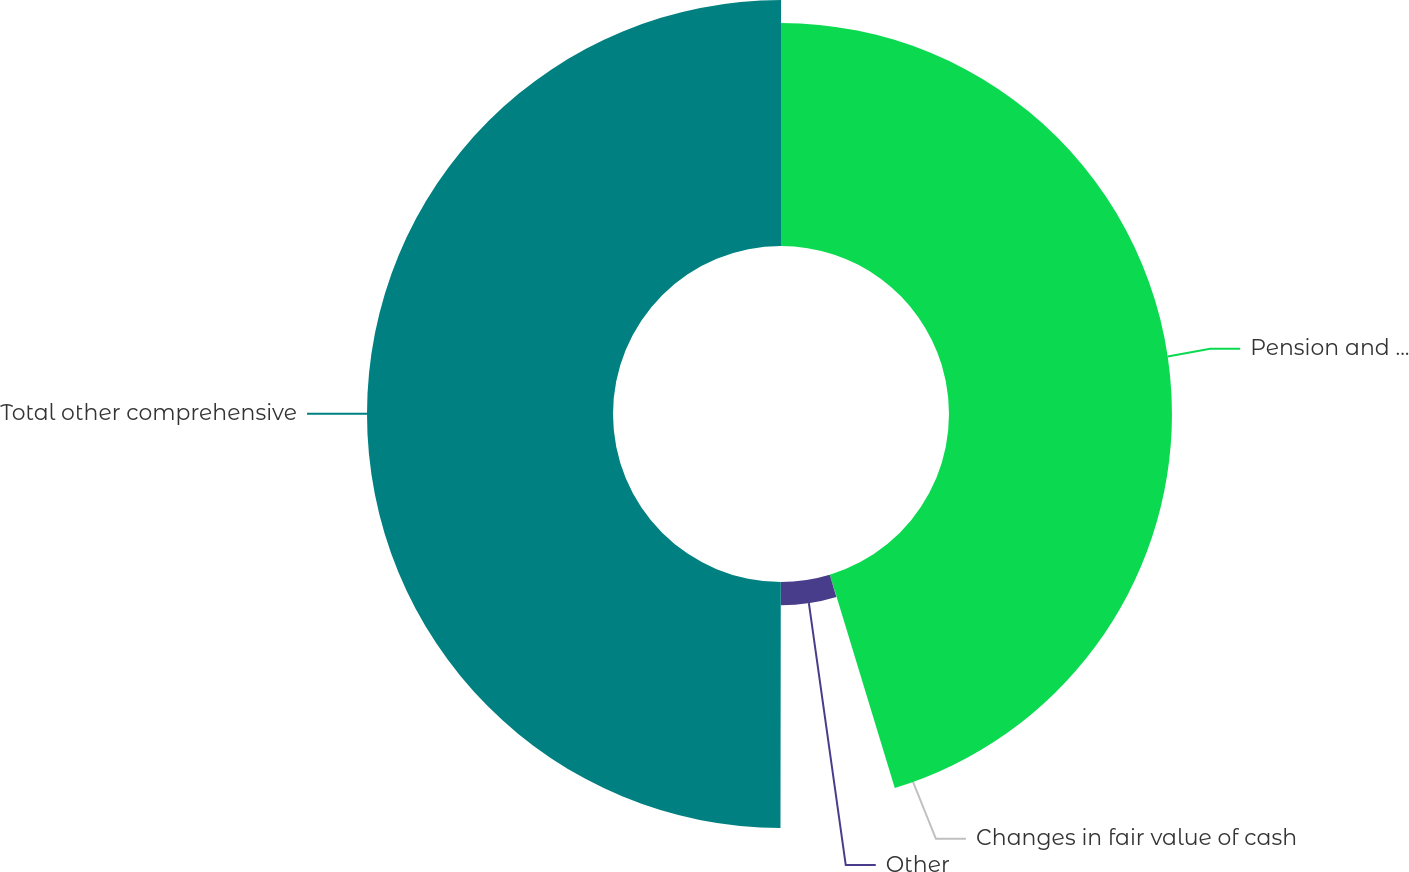<chart> <loc_0><loc_0><loc_500><loc_500><pie_chart><fcel>Pension and other<fcel>Changes in fair value of cash<fcel>Other<fcel>Total other comprehensive<nl><fcel>45.3%<fcel>0.02%<fcel>4.7%<fcel>49.98%<nl></chart> 